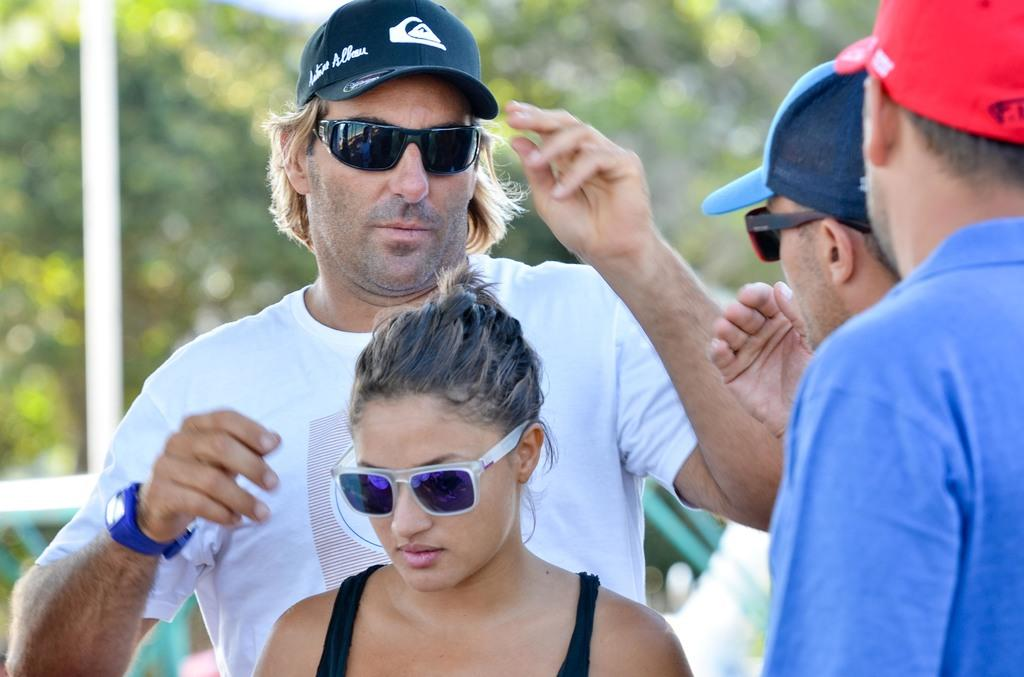What is the main subject of the image? The main subject of the image is people in the center. What can be seen in the background of the image? There are trees in the background of the image. What object is located on the left side of the image? There is a pole on the left side of the image. What type of fog can be seen surrounding the people in the image? There is no fog present in the image; it features people, trees, and a pole. What form does the reward take in the image? There is no reward present in the image. 